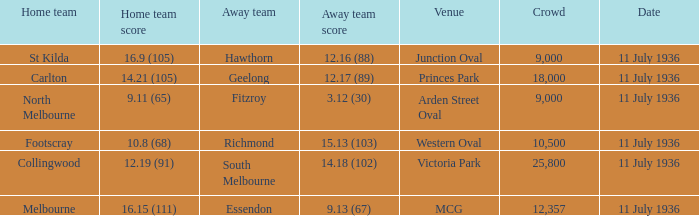What is the lowest crowd seen by the mcg Venue? 12357.0. 